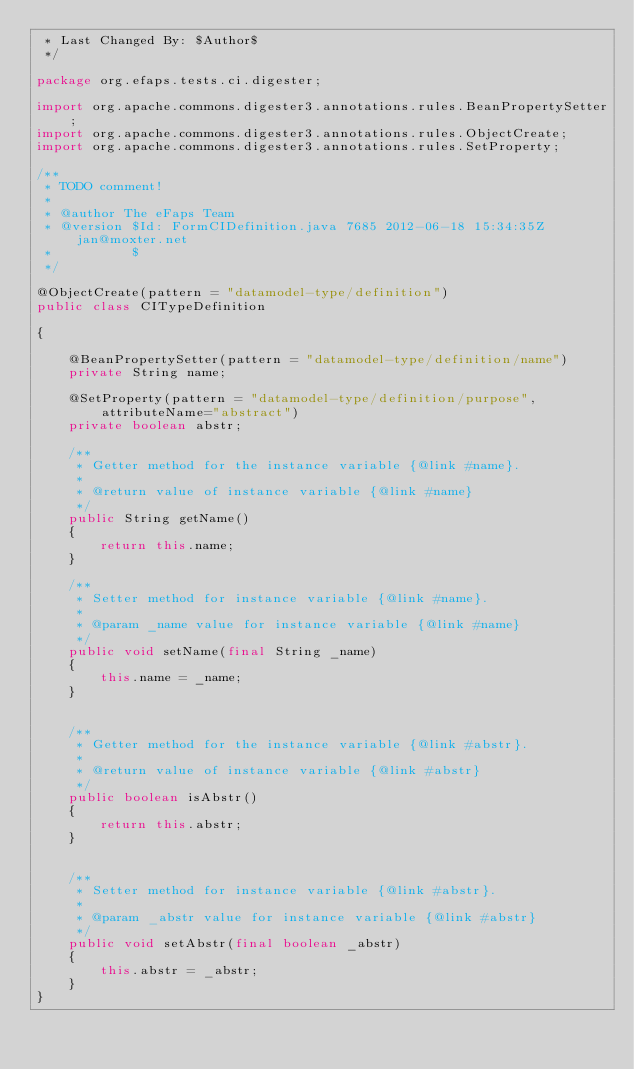<code> <loc_0><loc_0><loc_500><loc_500><_Java_> * Last Changed By: $Author$
 */

package org.efaps.tests.ci.digester;

import org.apache.commons.digester3.annotations.rules.BeanPropertySetter;
import org.apache.commons.digester3.annotations.rules.ObjectCreate;
import org.apache.commons.digester3.annotations.rules.SetProperty;

/**
 * TODO comment!
 *
 * @author The eFaps Team
 * @version $Id: FormCIDefinition.java 7685 2012-06-18 15:34:35Z jan@moxter.net
 *          $
 */

@ObjectCreate(pattern = "datamodel-type/definition")
public class CITypeDefinition

{

    @BeanPropertySetter(pattern = "datamodel-type/definition/name")
    private String name;

    @SetProperty(pattern = "datamodel-type/definition/purpose", attributeName="abstract")
    private boolean abstr;

    /**
     * Getter method for the instance variable {@link #name}.
     *
     * @return value of instance variable {@link #name}
     */
    public String getName()
    {
        return this.name;
    }

    /**
     * Setter method for instance variable {@link #name}.
     *
     * @param _name value for instance variable {@link #name}
     */
    public void setName(final String _name)
    {
        this.name = _name;
    }


    /**
     * Getter method for the instance variable {@link #abstr}.
     *
     * @return value of instance variable {@link #abstr}
     */
    public boolean isAbstr()
    {
        return this.abstr;
    }


    /**
     * Setter method for instance variable {@link #abstr}.
     *
     * @param _abstr value for instance variable {@link #abstr}
     */
    public void setAbstr(final boolean _abstr)
    {
        this.abstr = _abstr;
    }
}
</code> 